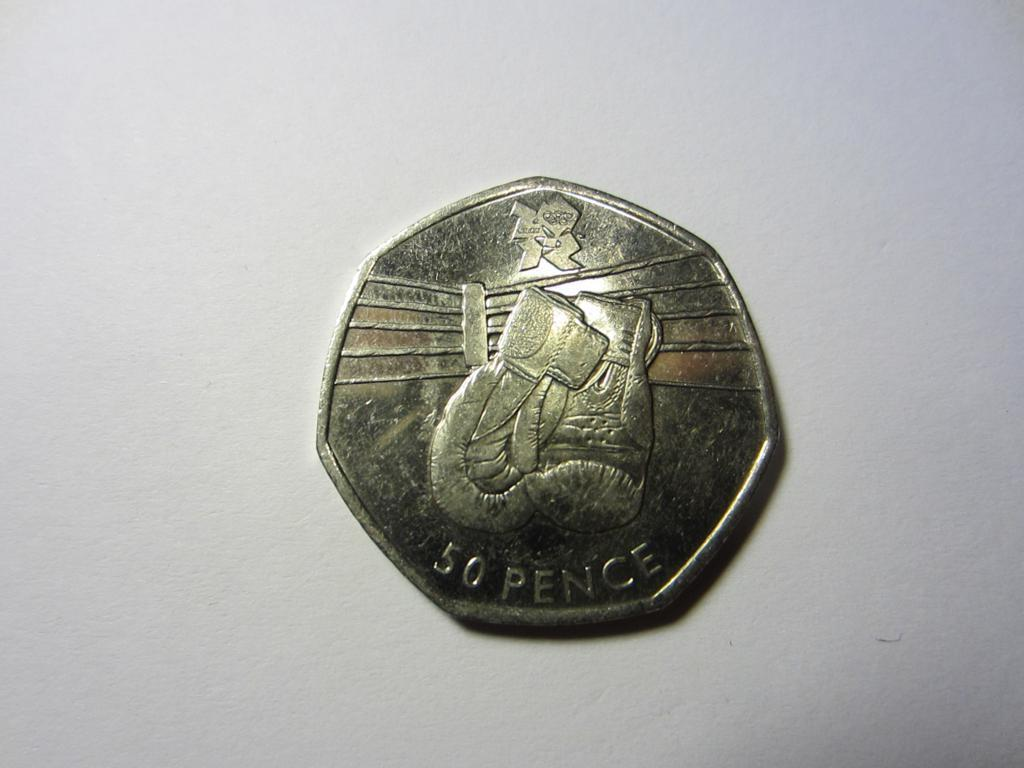<image>
Offer a succinct explanation of the picture presented. A gold coin that is worth 50 pence is on the table. 